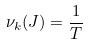Convert formula to latex. <formula><loc_0><loc_0><loc_500><loc_500>\nu _ { k } ( J ) = \frac { 1 } { T }</formula> 